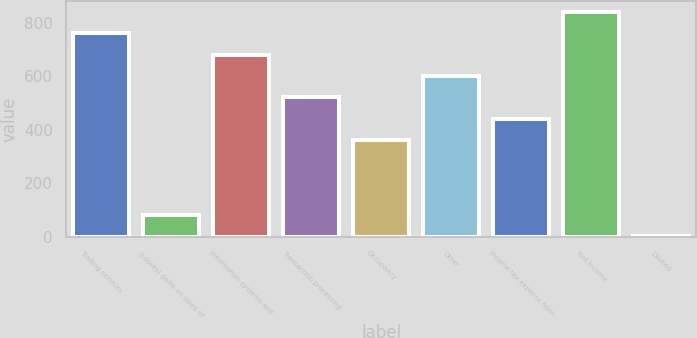Convert chart. <chart><loc_0><loc_0><loc_500><loc_500><bar_chart><fcel>Trading services<fcel>(Losses) gains on sales of<fcel>Information systems and<fcel>Transaction processing<fcel>Occupancy<fcel>Other<fcel>Income tax expense from<fcel>Net income<fcel>Diluted<nl><fcel>760.81<fcel>81.91<fcel>681.24<fcel>522.12<fcel>363<fcel>601.68<fcel>442.56<fcel>840.38<fcel>2.35<nl></chart> 